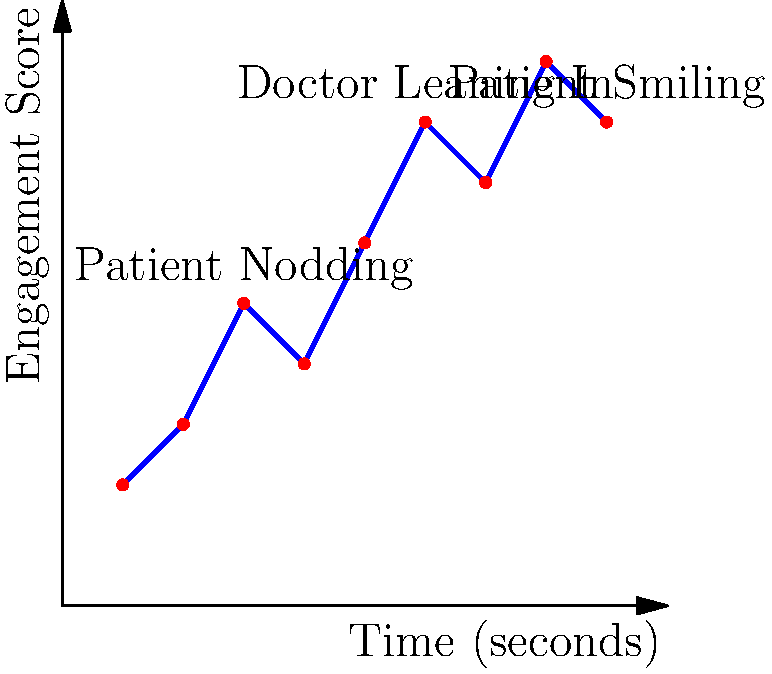In a study of patient-provider communication during cancer consultations, researchers used pose estimation to analyze body language and facial expressions. The graph shows the patient's engagement score over time, with key nonverbal cues noted. What is the average engagement score during the consultation, and how might this information be used to improve patient-provider communication? To answer this question, we need to follow these steps:

1. Calculate the average engagement score:
   a. Sum up all the engagement scores: 2 + 3 + 5 + 4 + 6 + 8 + 7 + 9 + 8 = 52
   b. Count the total number of data points: 9
   c. Calculate the average: 52 ÷ 9 ≈ 5.78

2. Interpret the graph and its implications for patient-provider communication:
   a. The graph shows an overall increasing trend in patient engagement.
   b. Specific nonverbal cues (patient nodding, doctor leaning in, patient smiling) correspond to higher engagement scores.
   c. The average engagement score of 5.78 indicates a moderate to high level of engagement throughout the consultation.

3. Consider how this information can be used to improve patient-provider communication:
   a. Providers can be trained to recognize and encourage positive nonverbal cues that increase patient engagement.
   b. The timing of important information delivery can be optimized for periods of higher patient engagement.
   c. Providers can learn to adjust their communication style based on the patient's engagement level.
   d. Researchers can further investigate the correlation between specific nonverbal cues and patient outcomes.

The average engagement score of 5.78 provides a baseline for comparison in future studies and can help identify consultations that may require additional attention or follow-up.
Answer: Average engagement score: 5.78. Use: Train providers to recognize and encourage positive nonverbal cues, optimize timing of information delivery, and adjust communication style based on engagement levels. 